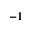Convert formula to latex. <formula><loc_0><loc_0><loc_500><loc_500>^ { - 1 }</formula> 